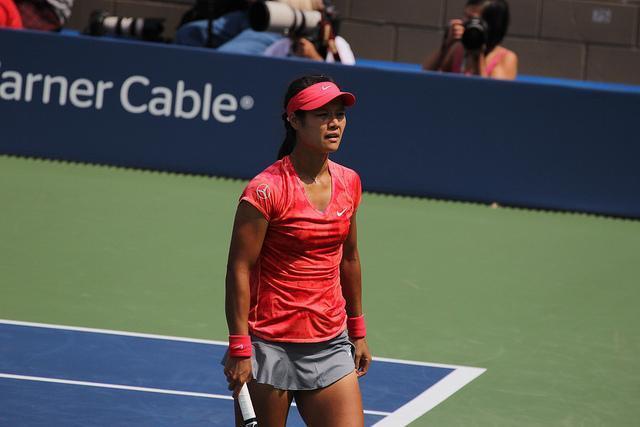How many people are in the picture?
Give a very brief answer. 4. How many bicycles are in this picture?
Give a very brief answer. 0. 